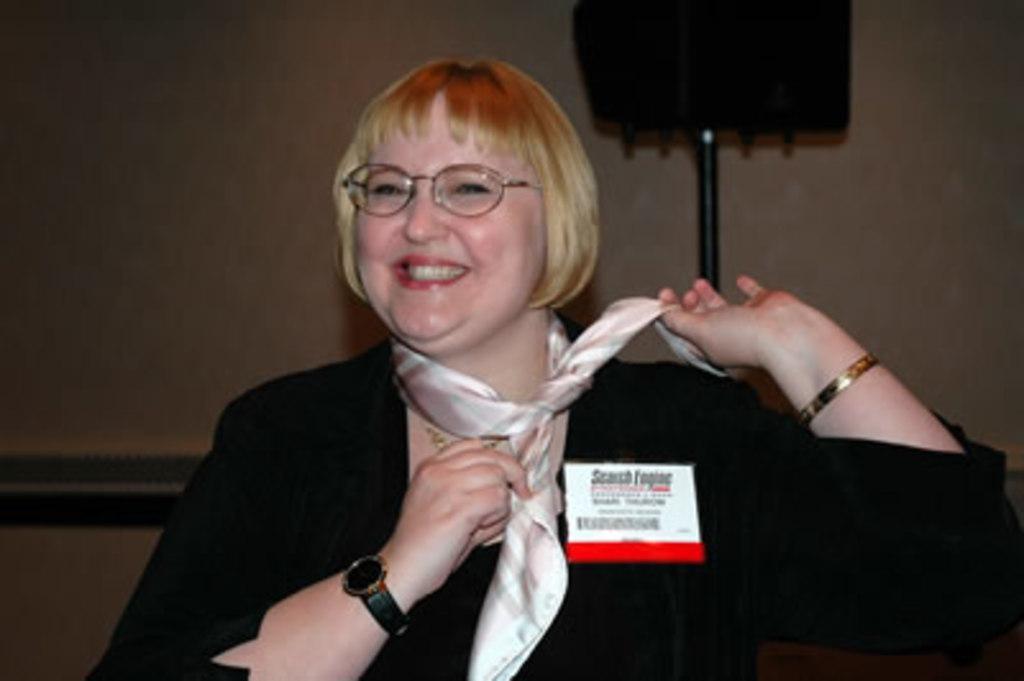Could you give a brief overview of what you see in this image? A woman is present in a room and smiling. She is wearing a black dress and a stole. There is a speaker at the right back. 